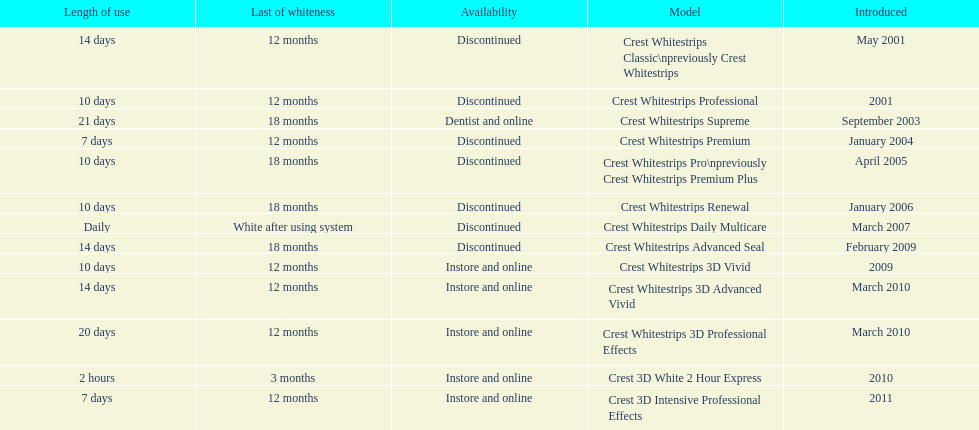What product was introduced in the same month as crest whitestrips 3d advanced vivid? Crest Whitestrips 3D Professional Effects. 